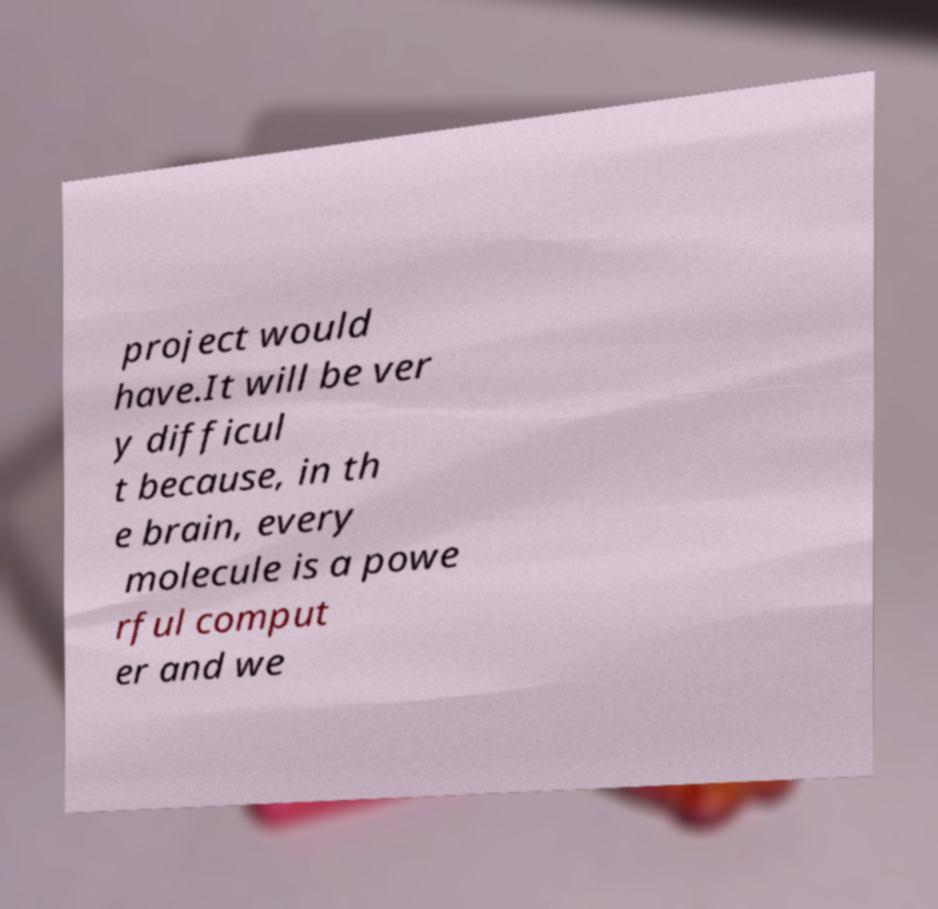Can you accurately transcribe the text from the provided image for me? project would have.It will be ver y difficul t because, in th e brain, every molecule is a powe rful comput er and we 